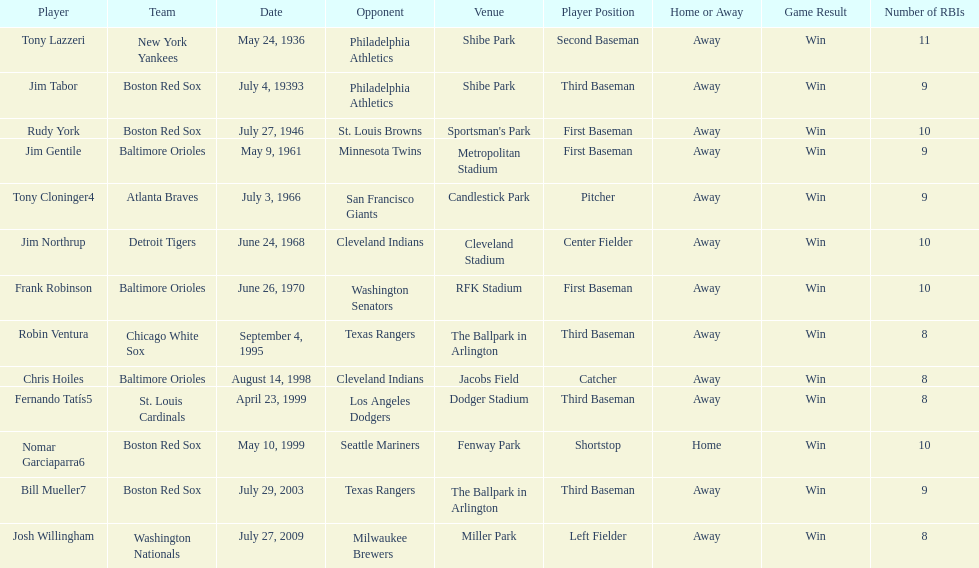Can you give me this table as a dict? {'header': ['Player', 'Team', 'Date', 'Opponent', 'Venue', 'Player Position', 'Home or Away', 'Game Result', 'Number of RBIs'], 'rows': [['Tony Lazzeri', 'New York Yankees', 'May 24, 1936', 'Philadelphia Athletics', 'Shibe Park', 'Second Baseman', 'Away', 'Win', '11'], ['Jim Tabor', 'Boston Red Sox', 'July 4, 19393', 'Philadelphia Athletics', 'Shibe Park', 'Third Baseman', 'Away', 'Win', '9'], ['Rudy York', 'Boston Red Sox', 'July 27, 1946', 'St. Louis Browns', "Sportsman's Park", 'First Baseman', 'Away', 'Win', '10'], ['Jim Gentile', 'Baltimore Orioles', 'May 9, 1961', 'Minnesota Twins', 'Metropolitan Stadium', 'First Baseman', 'Away', 'Win', '9'], ['Tony Cloninger4', 'Atlanta Braves', 'July 3, 1966', 'San Francisco Giants', 'Candlestick Park', 'Pitcher', 'Away', 'Win', '9'], ['Jim Northrup', 'Detroit Tigers', 'June 24, 1968', 'Cleveland Indians', 'Cleveland Stadium', 'Center Fielder', 'Away', 'Win', '10'], ['Frank Robinson', 'Baltimore Orioles', 'June 26, 1970', 'Washington Senators', 'RFK Stadium', 'First Baseman', 'Away', 'Win', '10'], ['Robin Ventura', 'Chicago White Sox', 'September 4, 1995', 'Texas Rangers', 'The Ballpark in Arlington', 'Third Baseman', 'Away', 'Win', '8'], ['Chris Hoiles', 'Baltimore Orioles', 'August 14, 1998', 'Cleveland Indians', 'Jacobs Field', 'Catcher', 'Away', 'Win', '8'], ['Fernando Tatís5', 'St. Louis Cardinals', 'April 23, 1999', 'Los Angeles Dodgers', 'Dodger Stadium', 'Third Baseman', 'Away', 'Win', '8'], ['Nomar Garciaparra6', 'Boston Red Sox', 'May 10, 1999', 'Seattle Mariners', 'Fenway Park', 'Shortstop', 'Home', 'Win', '10'], ['Bill Mueller7', 'Boston Red Sox', 'July 29, 2003', 'Texas Rangers', 'The Ballpark in Arlington', 'Third Baseman', 'Away', 'Win', '9'], ['Josh Willingham', 'Washington Nationals', 'July 27, 2009', 'Milwaukee Brewers', 'Miller Park', 'Left Fielder', 'Away', 'Win', '8']]} What is the name of the player for the new york yankees in 1936? Tony Lazzeri. 